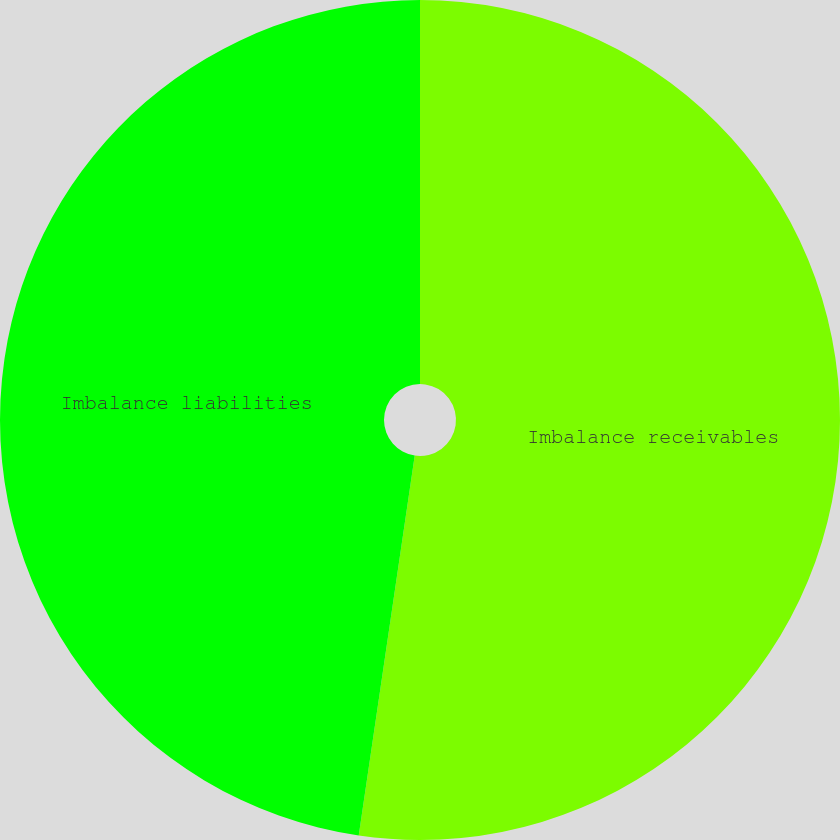<chart> <loc_0><loc_0><loc_500><loc_500><pie_chart><fcel>Imbalance receivables<fcel>Imbalance liabilities<nl><fcel>52.33%<fcel>47.67%<nl></chart> 